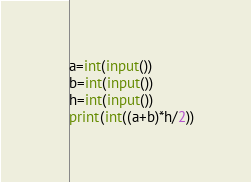Convert code to text. <code><loc_0><loc_0><loc_500><loc_500><_Python_>a=int(input())
b=int(input())
h=int(input())
print(int((a+b)*h/2))</code> 